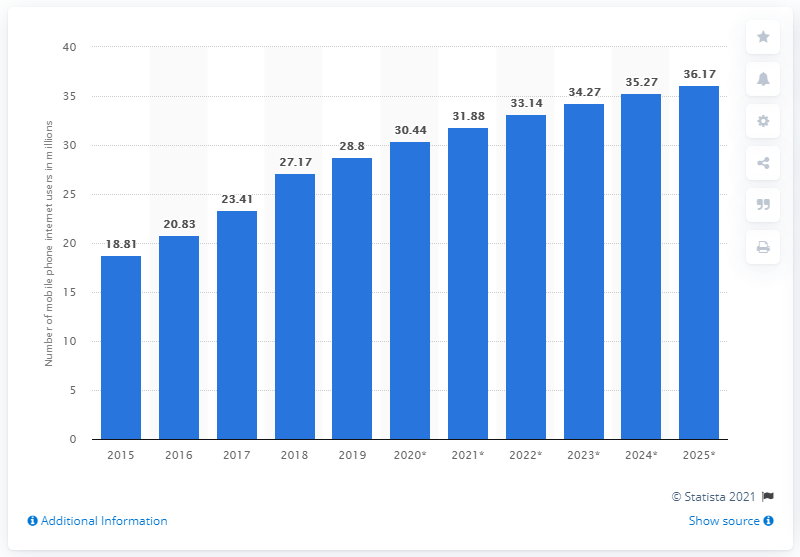List a handful of essential elements in this visual. In 2019, there were 28.8 million mobile internet users in Saudi Arabia. In 2025, it is projected that there will be approximately 36.17 million mobile internet users in Saudi Arabia. According to estimates, the number of internet users in Saudi Arabia is projected to be 36.17 million in 2025. In 2019, the number of mobile internet users in Saudi Arabia was 28.8%. 